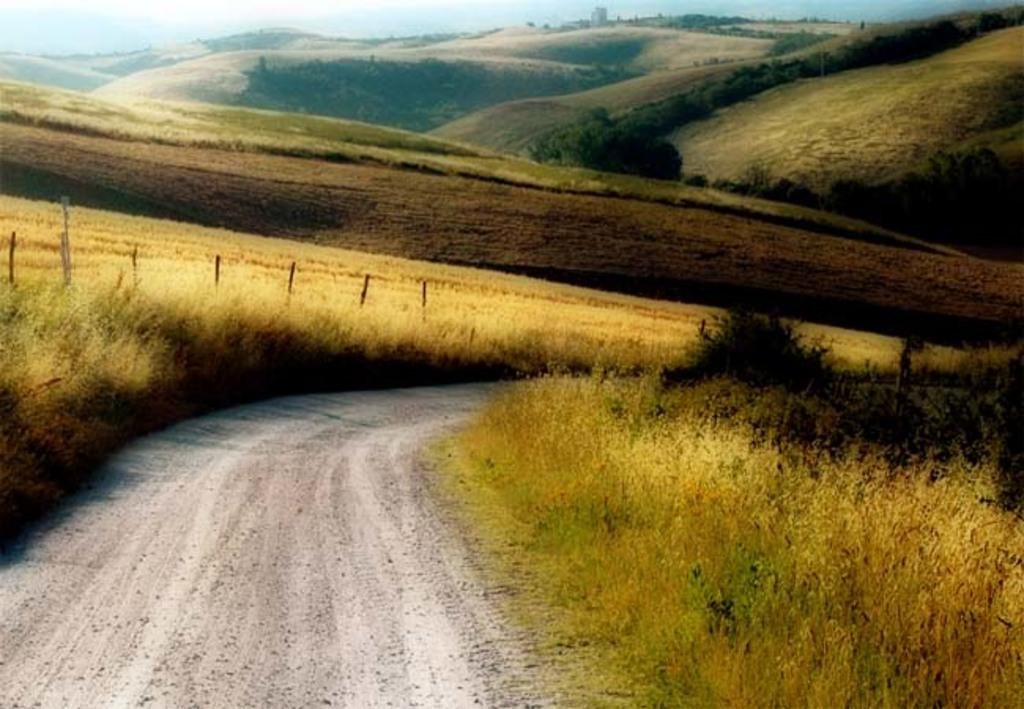What type of vegetation is on the right side of the image? There are plants on the right side of the image. What objects are on the left side of the image? There are wooden sticks on the left side of the image. What can be seen at the bottom of the image? There is a walkway at the bottom of the image. What natural features are visible in the background of the image? There are mountains and trees in the background of the image. Can you see a group of people playing with a cap in the image? There is no group of people playing with a cap in the image. What type of cap is visible in the image? There is no cap present in the image. 